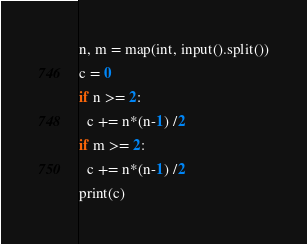Convert code to text. <code><loc_0><loc_0><loc_500><loc_500><_Python_>n, m = map(int, input().split())
c = 0
if n >= 2:
  c += n*(n-1) /2
if m >= 2:
  c += n*(n-1) /2
print(c)</code> 